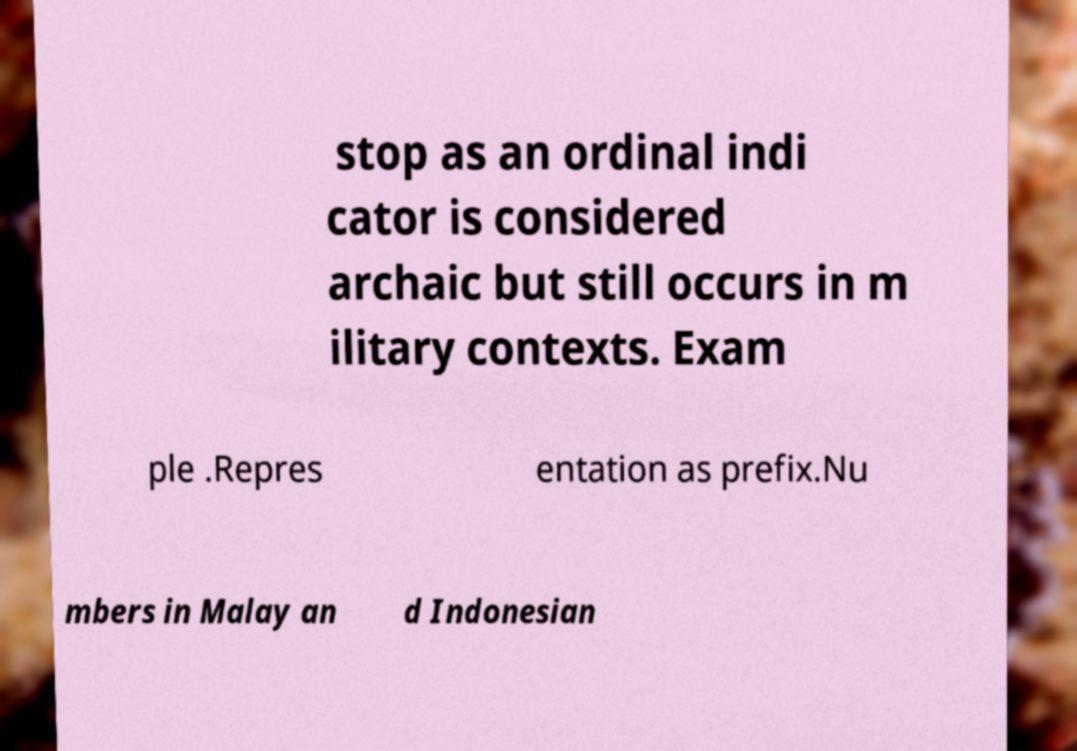For documentation purposes, I need the text within this image transcribed. Could you provide that? stop as an ordinal indi cator is considered archaic but still occurs in m ilitary contexts. Exam ple .Repres entation as prefix.Nu mbers in Malay an d Indonesian 